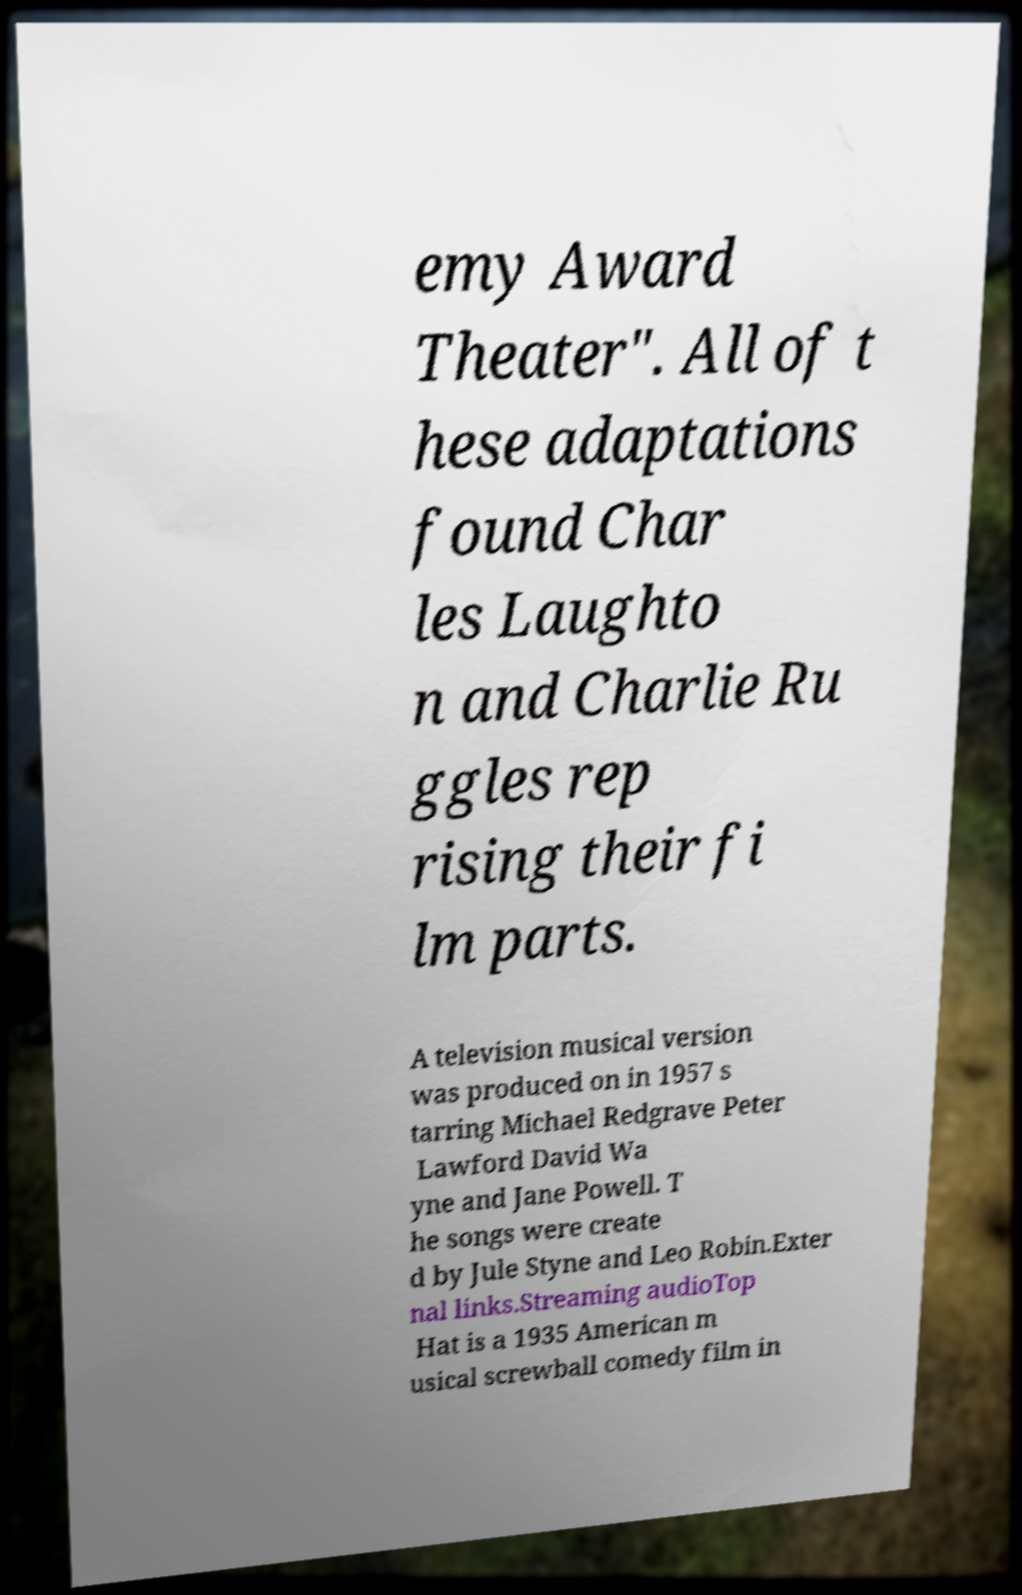Could you assist in decoding the text presented in this image and type it out clearly? emy Award Theater". All of t hese adaptations found Char les Laughto n and Charlie Ru ggles rep rising their fi lm parts. A television musical version was produced on in 1957 s tarring Michael Redgrave Peter Lawford David Wa yne and Jane Powell. T he songs were create d by Jule Styne and Leo Robin.Exter nal links.Streaming audioTop Hat is a 1935 American m usical screwball comedy film in 